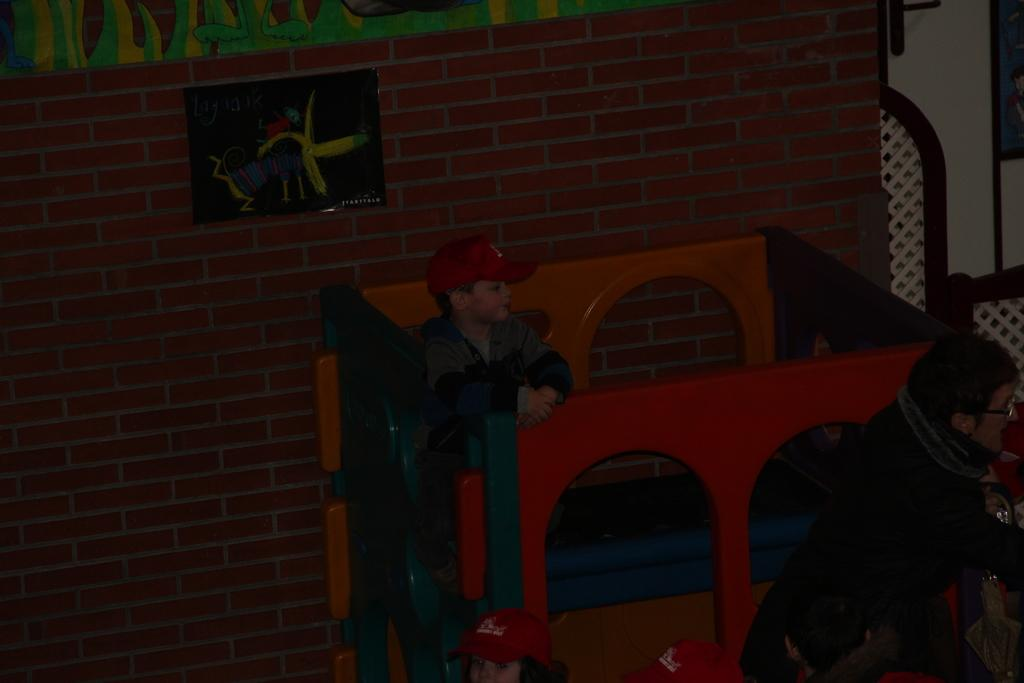What type of structure is visible in the image? There is a brick wall in the image. What is located in front of the brick wall? There is a playing tool in front of the brick wall. Who is on the playing tool? A boy is on the playing tool. Who else is present in the image? There is a woman in the image, and two kids are in front of her. What type of church can be seen in the image? There is no church present in the image. What show is the boy performing on the playing tool? The image does not depict a show or performance; it simply shows a boy on a playing tool. 